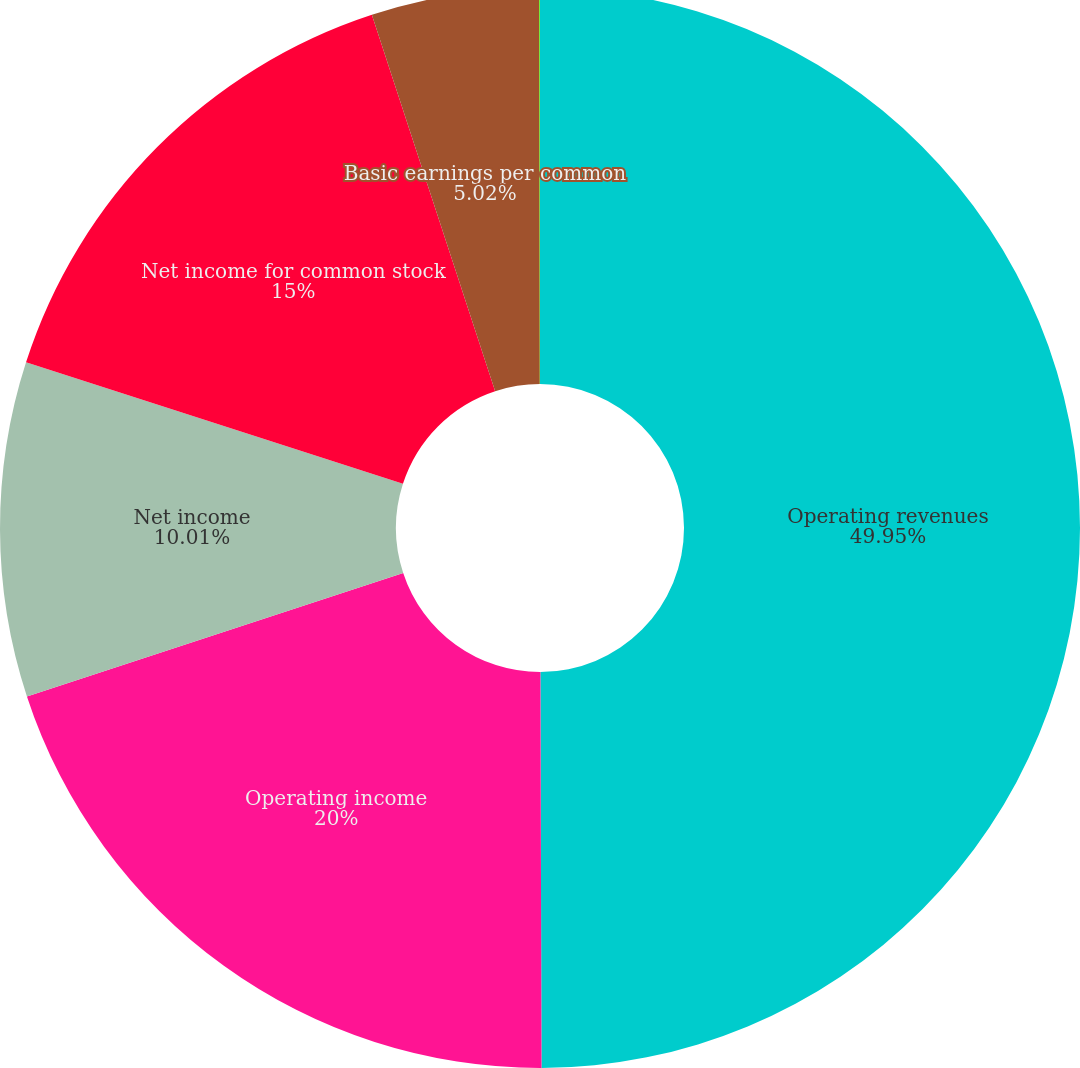Convert chart to OTSL. <chart><loc_0><loc_0><loc_500><loc_500><pie_chart><fcel>Operating revenues<fcel>Operating income<fcel>Net income<fcel>Net income for common stock<fcel>Basic earnings per common<fcel>Diluted earnings per common<nl><fcel>49.96%<fcel>20.0%<fcel>10.01%<fcel>15.0%<fcel>5.02%<fcel>0.02%<nl></chart> 